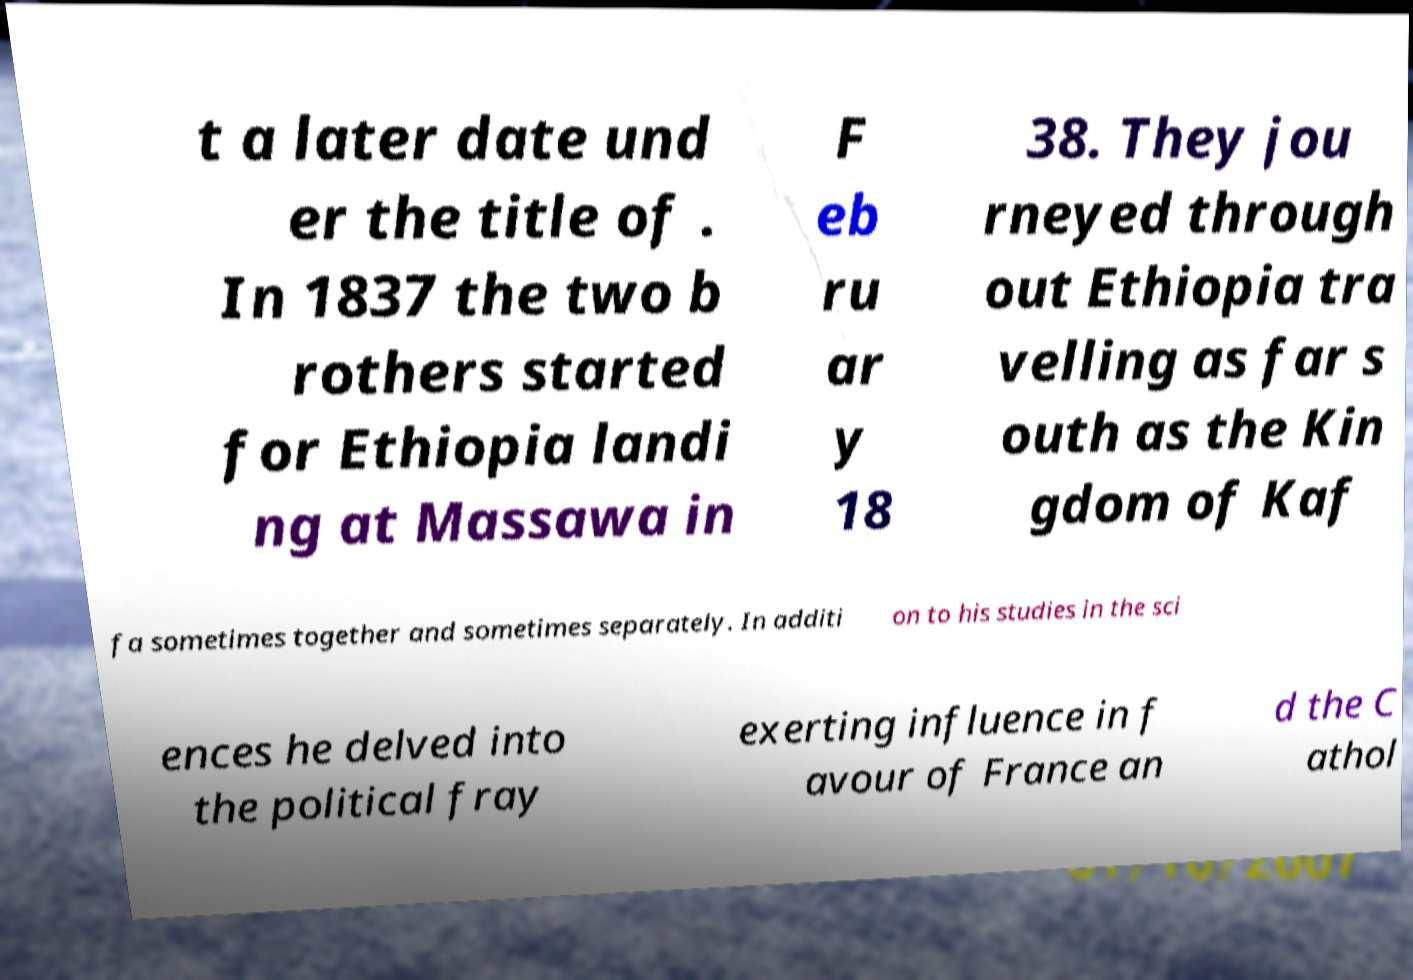Can you read and provide the text displayed in the image?This photo seems to have some interesting text. Can you extract and type it out for me? t a later date und er the title of . In 1837 the two b rothers started for Ethiopia landi ng at Massawa in F eb ru ar y 18 38. They jou rneyed through out Ethiopia tra velling as far s outh as the Kin gdom of Kaf fa sometimes together and sometimes separately. In additi on to his studies in the sci ences he delved into the political fray exerting influence in f avour of France an d the C athol 